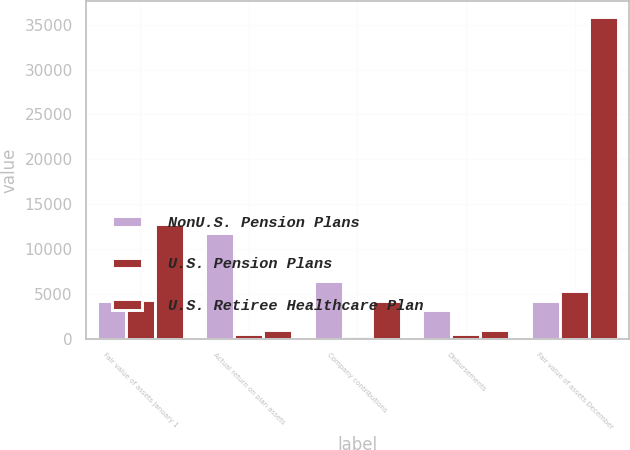Convert chart to OTSL. <chart><loc_0><loc_0><loc_500><loc_500><stacked_bar_chart><ecel><fcel>Fair value of assets January 1<fcel>Actual return on plan assets<fcel>Company contributions<fcel>Disbursements<fcel>Fair value of assets December<nl><fcel>NonU.S. Pension Plans<fcel>4243<fcel>11761<fcel>6409<fcel>3208<fcel>4243<nl><fcel>U.S. Pension Plans<fcel>4319<fcel>516<fcel>275<fcel>480<fcel>5357<nl><fcel>U.S. Retiree Healthcare Plan<fcel>12798<fcel>1007<fcel>4243<fcel>1011<fcel>35859<nl></chart> 